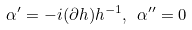<formula> <loc_0><loc_0><loc_500><loc_500>\alpha ^ { \prime } = - i ( \partial h ) h ^ { - 1 } , \ \alpha ^ { \prime \prime } = 0</formula> 